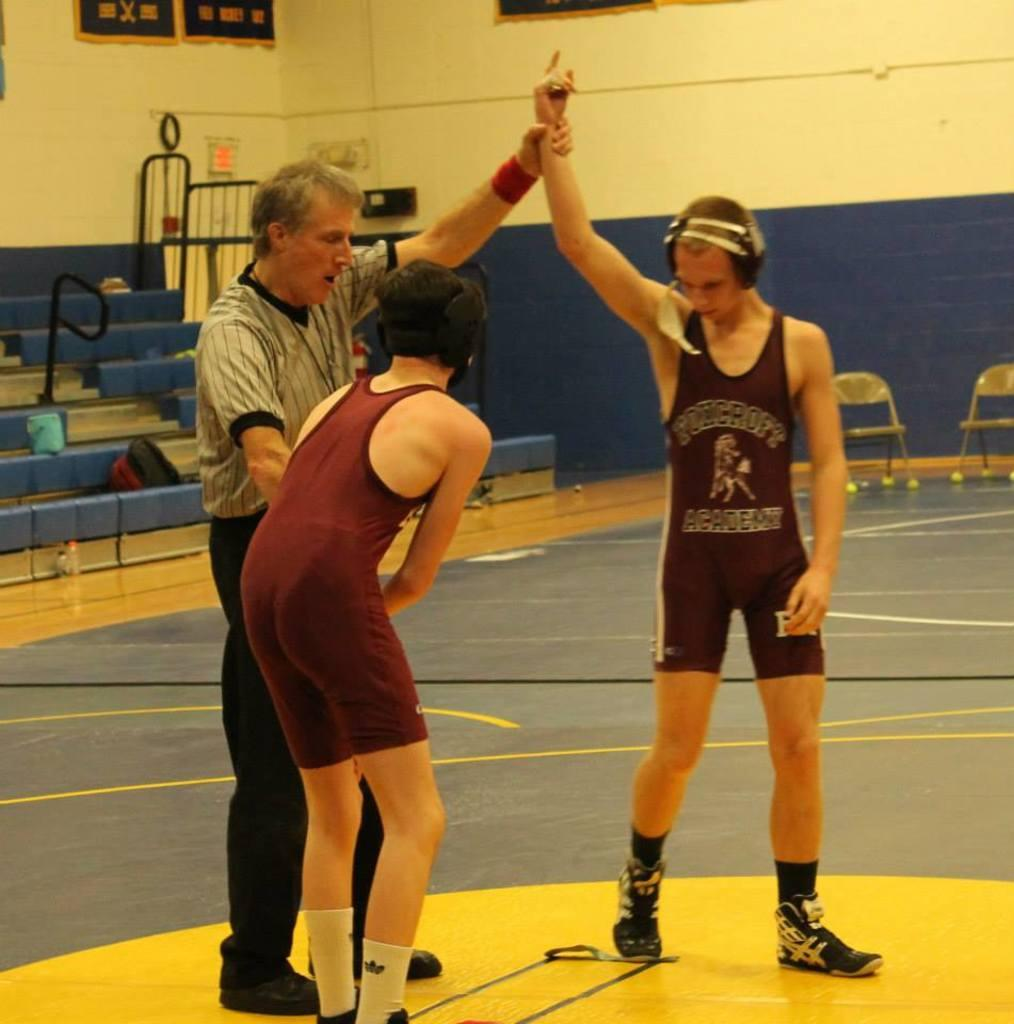<image>
Present a compact description of the photo's key features. the word academy is on the front of the person's outfit 